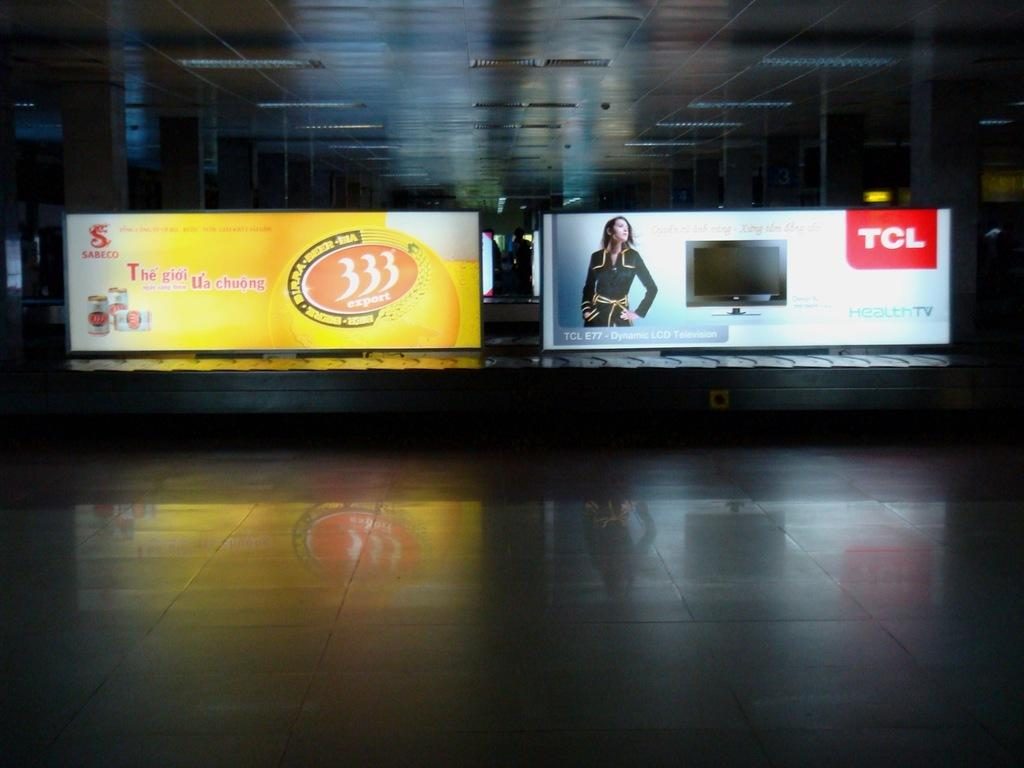<image>
Summarize the visual content of the image. A person is on a billboard for a TV ad that says TCL. 